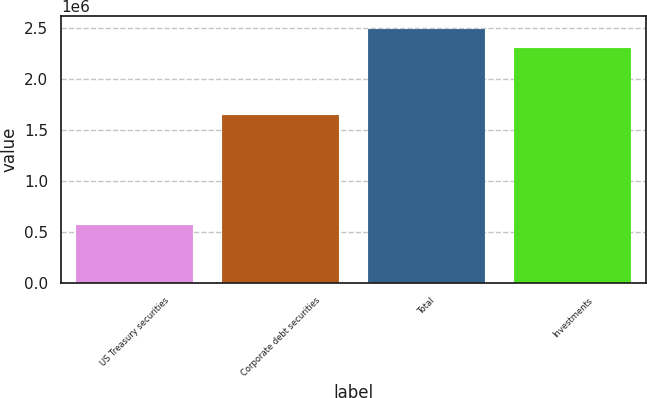Convert chart to OTSL. <chart><loc_0><loc_0><loc_500><loc_500><bar_chart><fcel>US Treasury securities<fcel>Corporate debt securities<fcel>Total<fcel>Investments<nl><fcel>570313<fcel>1.64384e+06<fcel>2.49359e+06<fcel>2.3074e+06<nl></chart> 